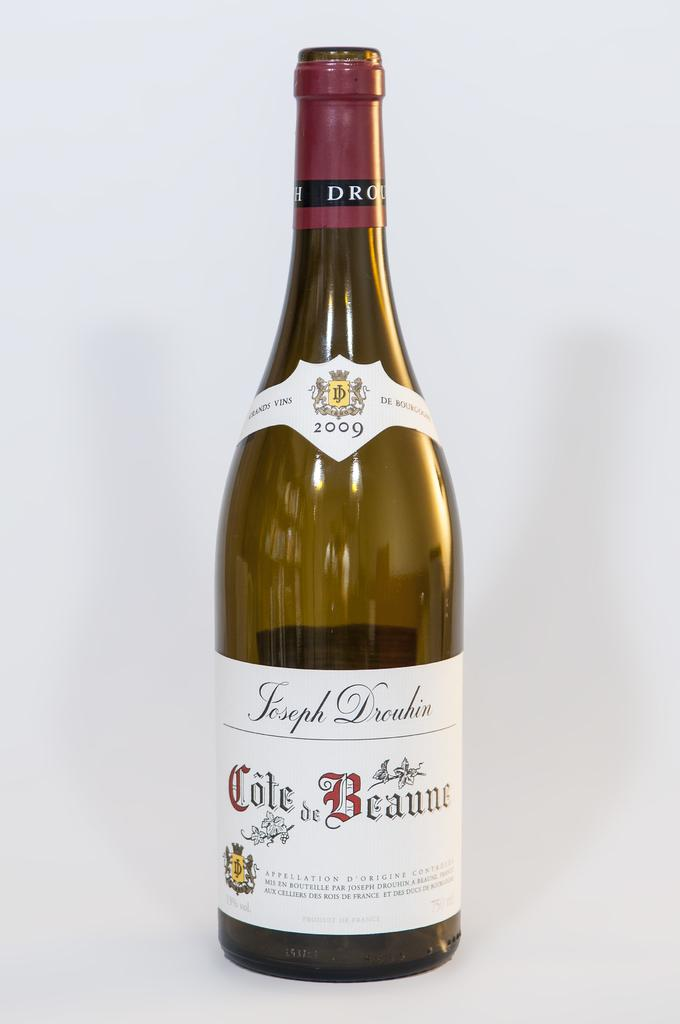<image>
Write a terse but informative summary of the picture. a bottle of 2009 cole de beaune in a white label 